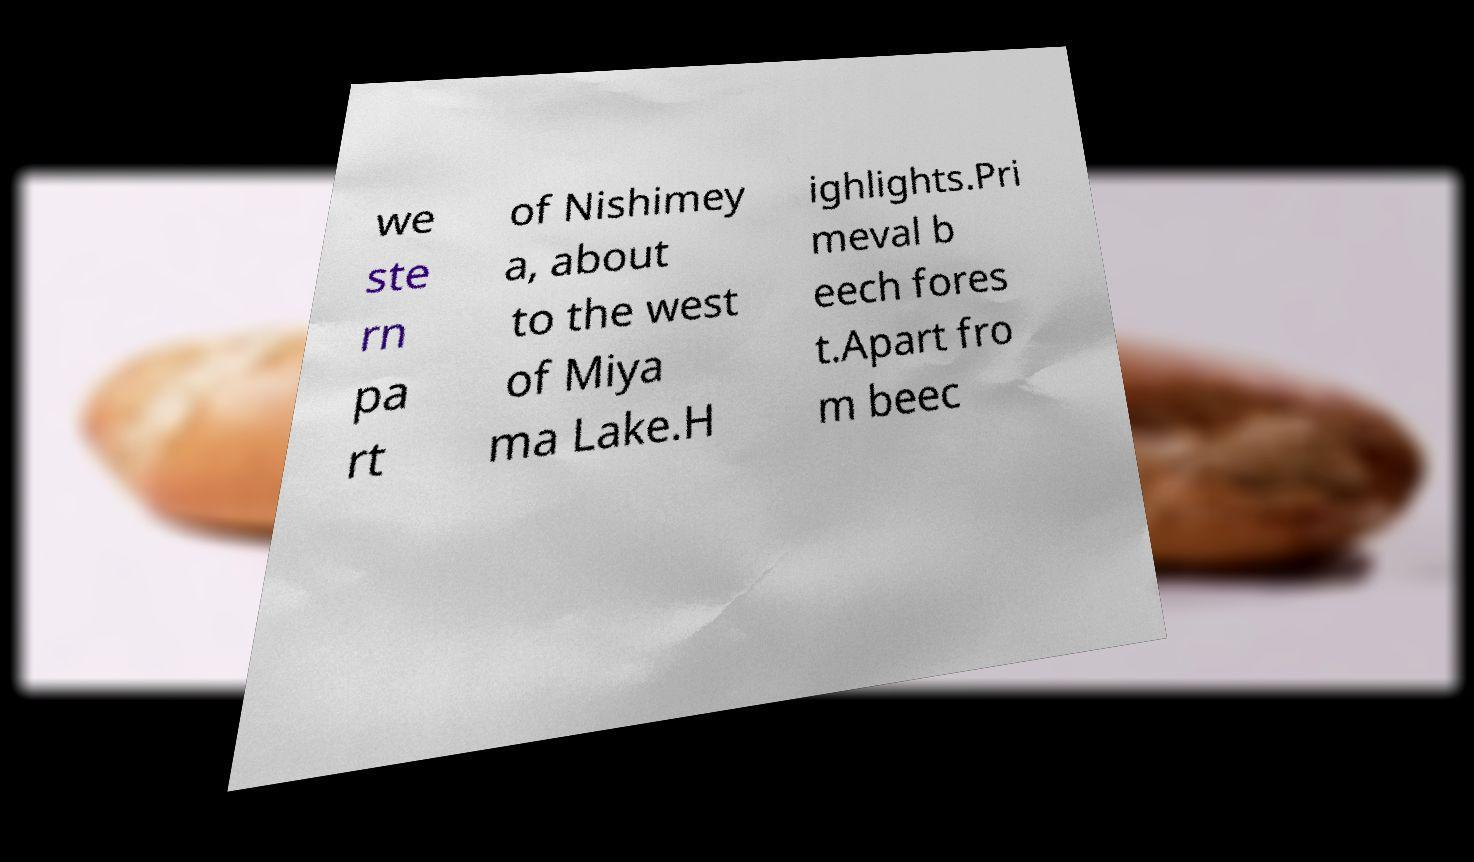I need the written content from this picture converted into text. Can you do that? we ste rn pa rt of Nishimey a, about to the west of Miya ma Lake.H ighlights.Pri meval b eech fores t.Apart fro m beec 